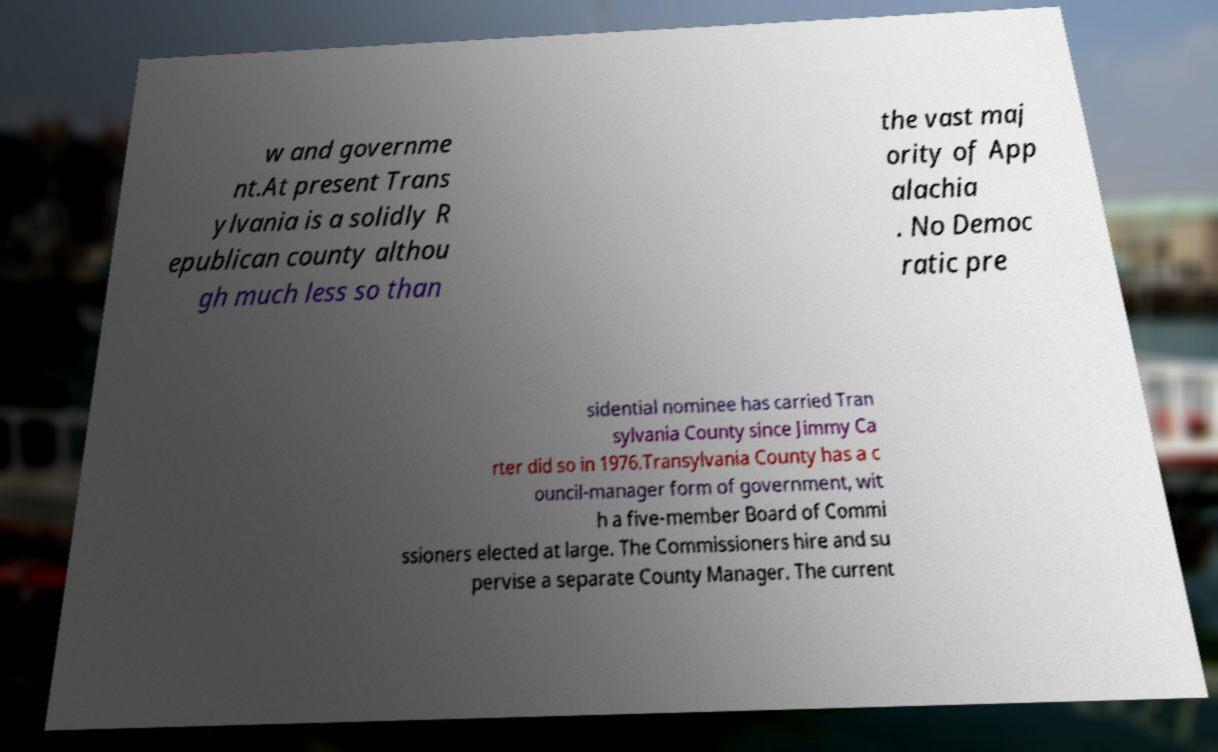There's text embedded in this image that I need extracted. Can you transcribe it verbatim? w and governme nt.At present Trans ylvania is a solidly R epublican county althou gh much less so than the vast maj ority of App alachia . No Democ ratic pre sidential nominee has carried Tran sylvania County since Jimmy Ca rter did so in 1976.Transylvania County has a c ouncil-manager form of government, wit h a five-member Board of Commi ssioners elected at large. The Commissioners hire and su pervise a separate County Manager. The current 